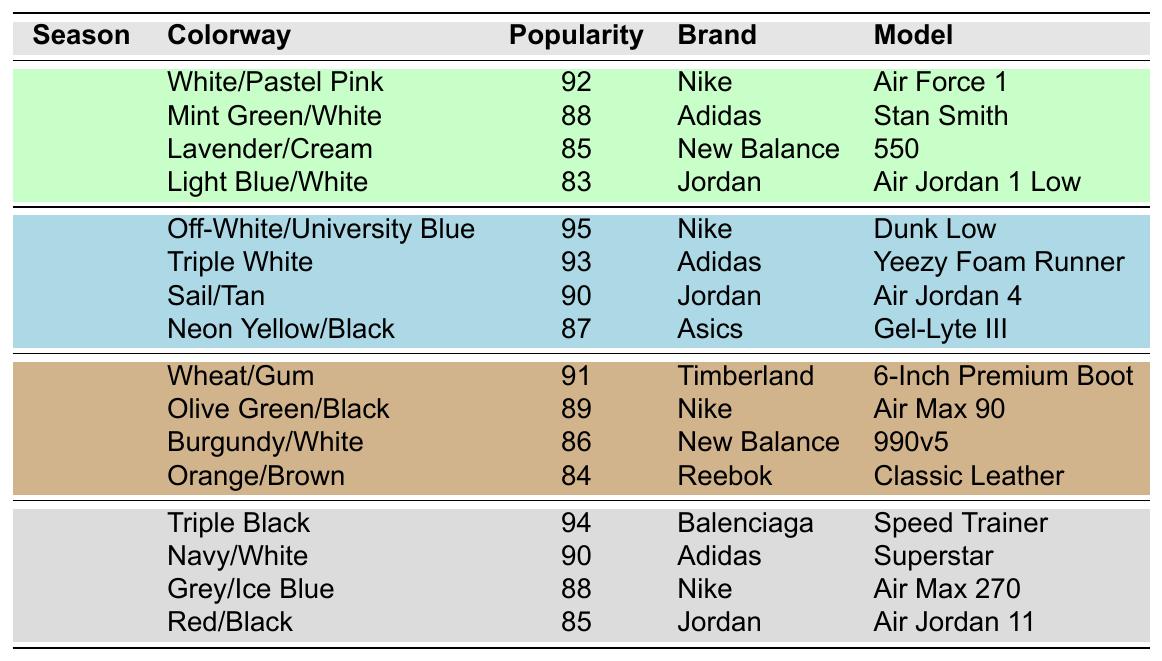What's the most popular colorway in the Summer season? The Summer colorway with the highest popularity score is "Off-White/University Blue," which has a score of 95.
Answer: Off-White/University Blue Which brand has the most popular sneaker in Spring? In Spring, the most popular sneaker is the Nike Air Force 1, with a popularity score of 92, making Nike the leading brand for this season.
Answer: Nike What is the average popularity score of Fall sneakers? The Fall sneakers have popularity scores of 91, 89, 86, and 84. Adding these scores gives 91 + 89 + 86 + 84 = 350. Dividing by 4 (the number of models) gives an average of 350 / 4 = 87.5.
Answer: 87.5 Is "Red/Black" a colorway in Winter? Yes, the colorway "Red/Black" is listed under Winter with a popularity score of 85.
Answer: Yes Which season has the highest overall popularity score for its colorways? Summing the popularity scores for each season: Spring (92 + 88 + 85 + 83 = 348), Summer (95 + 93 + 90 + 87 = 365), Fall (91 + 89 + 86 + 84 = 350), and Winter (94 + 90 + 88 + 85 = 357). Summer has the highest total score of 365.
Answer: Summer What is the least popular colorway in Spring? In Spring, the least popular colorway is "Light Blue/White," with a score of 83, making it the lowest among the Spring options.
Answer: Light Blue/White Are there any sneakers from Adidas in Fall? No, there are no Adidas sneakers listed in the Fall season; all the Fall options come from Timberland, Nike, New Balance, and Reebok.
Answer: No Which model has a higher popularity score: "Jordan Air Jordan 4" or "Nike Air Max 90"? The popularity score for "Jordan Air Jordan 4" is 90, while "Nike Air Max 90" has a score of 89. Since 90 is greater than 89, the Jordan model is more popular.
Answer: Jordan Air Jordan 4 What is the total score for Winter season colorways? The scores for Winter are 94, 90, 88, and 85. Adding these gives 94 + 90 + 88 + 85 = 357, so the total score for Winter is 357.
Answer: 357 